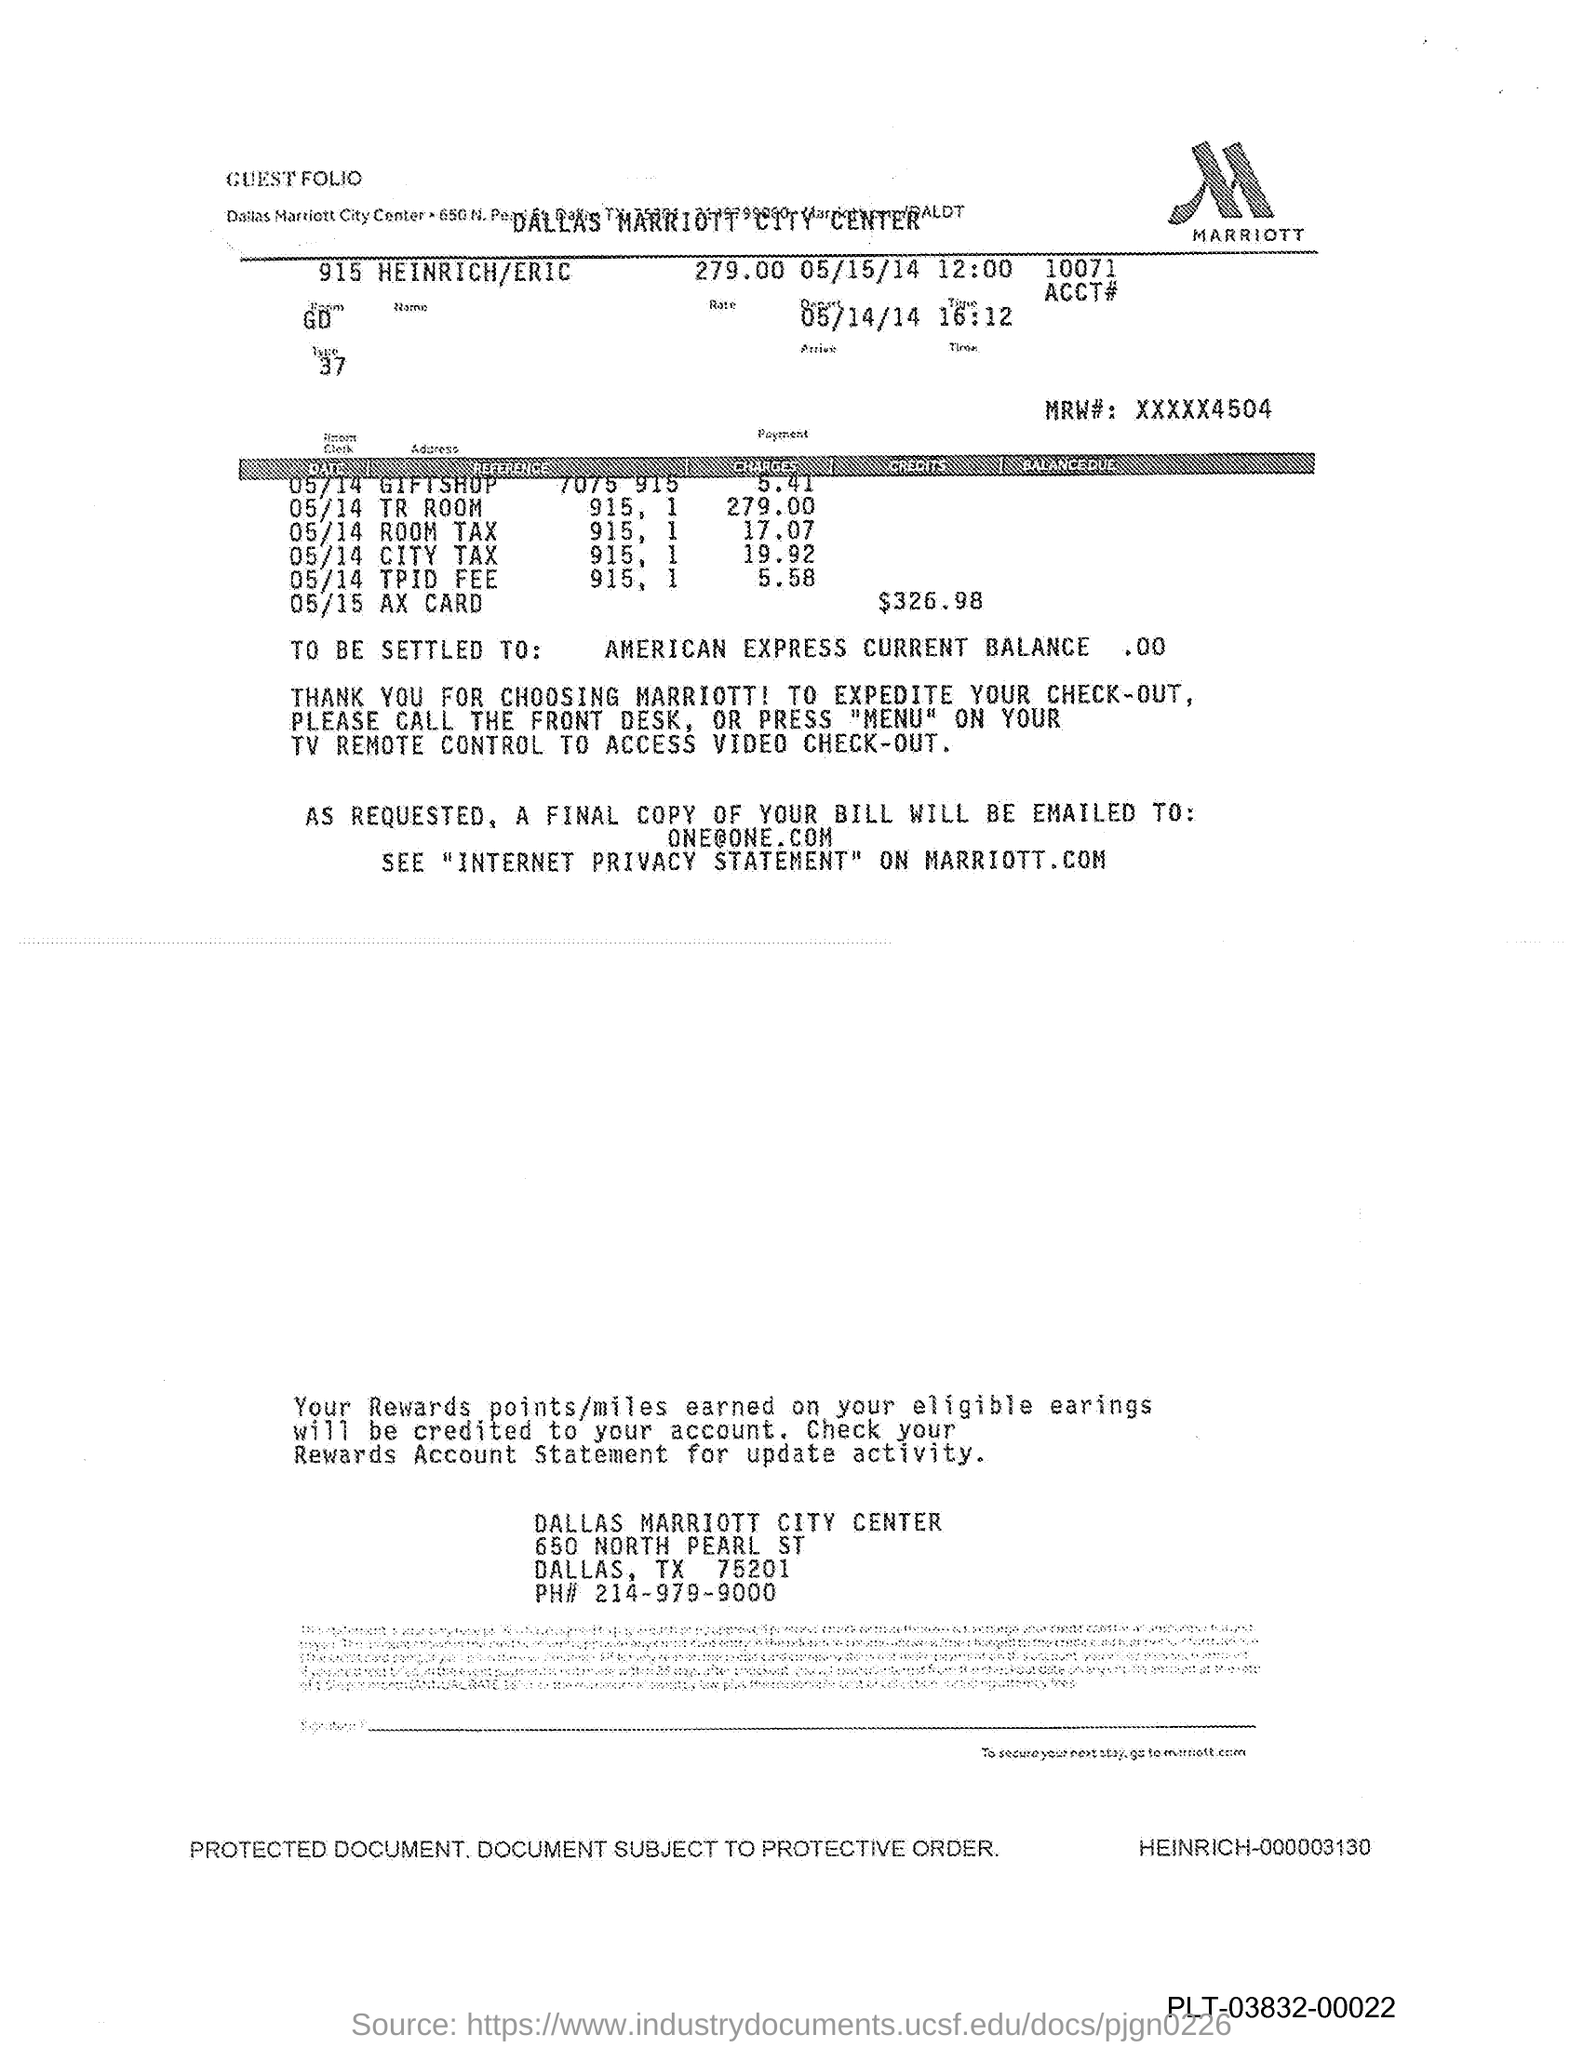Mention a couple of crucial points in this snapshot. The phone number for the Dallas Marriott City Center is 214-979-9000. To access video check-out functionality using a TV remote, please press the 'menu' button. The logo is named MARRIOTT. The current balance of American Express is $0.00. 